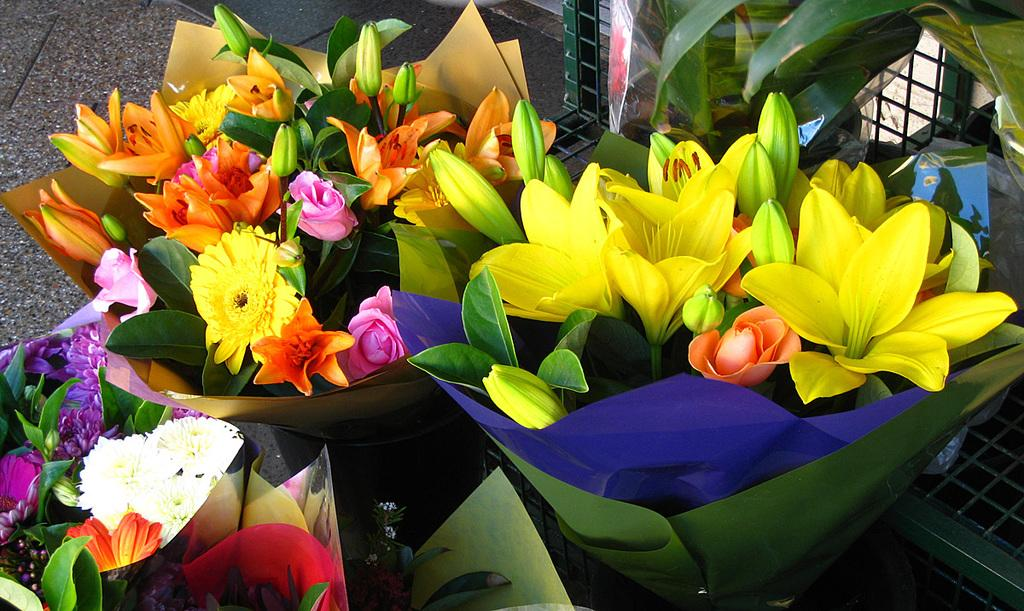What type of objects are in the image? There are flower bouquets in the image. Where are the flower bouquets located? The flower bouquets are placed on the ground. What type of stamp can be seen on the flowers in the image? There is no stamp present on the flowers in the image. What is the size of the field where the flower bouquets are located? The image does not provide information about the size of the field or any field at all. 